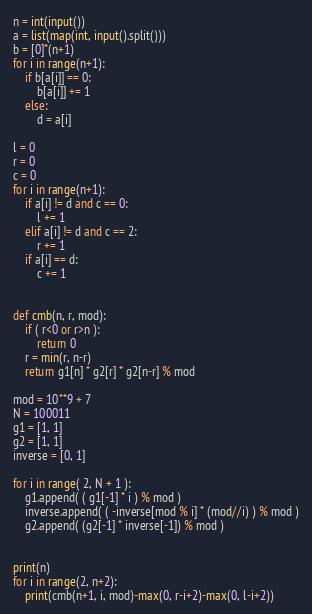Convert code to text. <code><loc_0><loc_0><loc_500><loc_500><_Python_>n = int(input())
a = list(map(int, input().split()))
b = [0]*(n+1)
for i in range(n+1):
    if b[a[i]] == 0:
        b[a[i]] += 1
    else:
        d = a[i]

l = 0
r = 0
c = 0
for i in range(n+1):
    if a[i] != d and c == 0:
        l += 1
    elif a[i] != d and c == 2:
        r += 1
    if a[i] == d:
        c += 1


def cmb(n, r, mod):
    if ( r<0 or r>n ):
        return 0
    r = min(r, n-r)
    return g1[n] * g2[r] * g2[n-r] % mod

mod = 10**9 + 7
N = 100011
g1 = [1, 1]
g2 = [1, 1]
inverse = [0, 1]

for i in range( 2, N + 1 ):
    g1.append( ( g1[-1] * i ) % mod )
    inverse.append( ( -inverse[mod % i] * (mod//i) ) % mod )
    g2.append( (g2[-1] * inverse[-1]) % mod )


print(n)
for i in range(2, n+2):
    print(cmb(n+1, i, mod)-max(0, r-i+2)-max(0, l-i+2))
</code> 